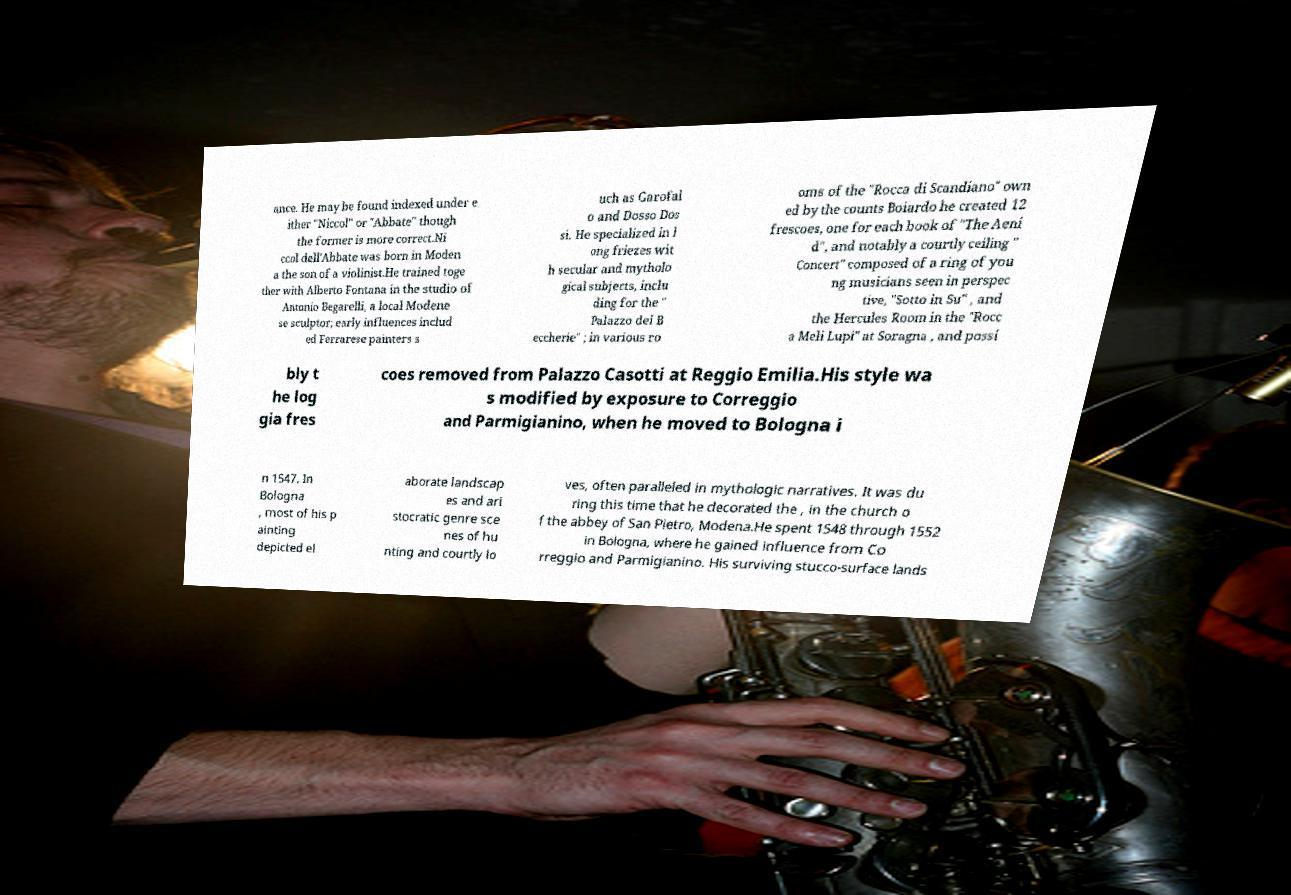Can you accurately transcribe the text from the provided image for me? ance. He may be found indexed under e ither "Niccol" or "Abbate" though the former is more correct.Ni ccol dell'Abbate was born in Moden a the son of a violinist.He trained toge ther with Alberto Fontana in the studio of Antonio Begarelli, a local Modene se sculptor; early influences includ ed Ferrarese painters s uch as Garofal o and Dosso Dos si. He specialized in l ong friezes wit h secular and mytholo gical subjects, inclu ding for the " Palazzo dei B eccherie" ; in various ro oms of the "Rocca di Scandiano" own ed by the counts Boiardo he created 12 frescoes, one for each book of "The Aeni d", and notably a courtly ceiling " Concert" composed of a ring of you ng musicians seen in perspec tive, "Sotto in Su" , and the Hercules Room in the "Rocc a Meli Lupi" at Soragna , and possi bly t he log gia fres coes removed from Palazzo Casotti at Reggio Emilia.His style wa s modified by exposure to Correggio and Parmigianino, when he moved to Bologna i n 1547. In Bologna , most of his p ainting depicted el aborate landscap es and ari stocratic genre sce nes of hu nting and courtly lo ves, often paralleled in mythologic narratives. It was du ring this time that he decorated the , in the church o f the abbey of San Pietro, Modena.He spent 1548 through 1552 in Bologna, where he gained influence from Co rreggio and Parmigianino. His surviving stucco-surface lands 